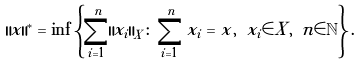<formula> <loc_0><loc_0><loc_500><loc_500>\| x \| ^ { * } = \inf \left \{ \sum _ { i = 1 } ^ { n } \| x _ { i } \| _ { X } \colon \sum _ { i = 1 } ^ { n } x _ { i } = x , \ x _ { i } \in X , \ n \in \mathbb { N } \right \} .</formula> 